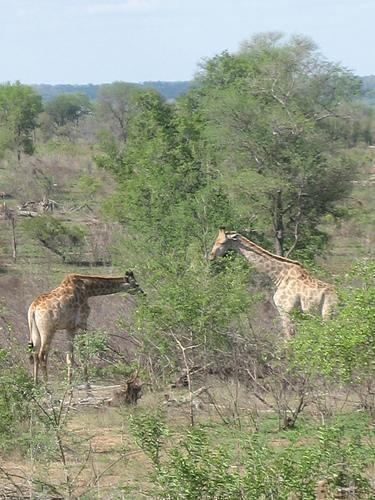How many giraffes are pictured?
Give a very brief answer. 2. 